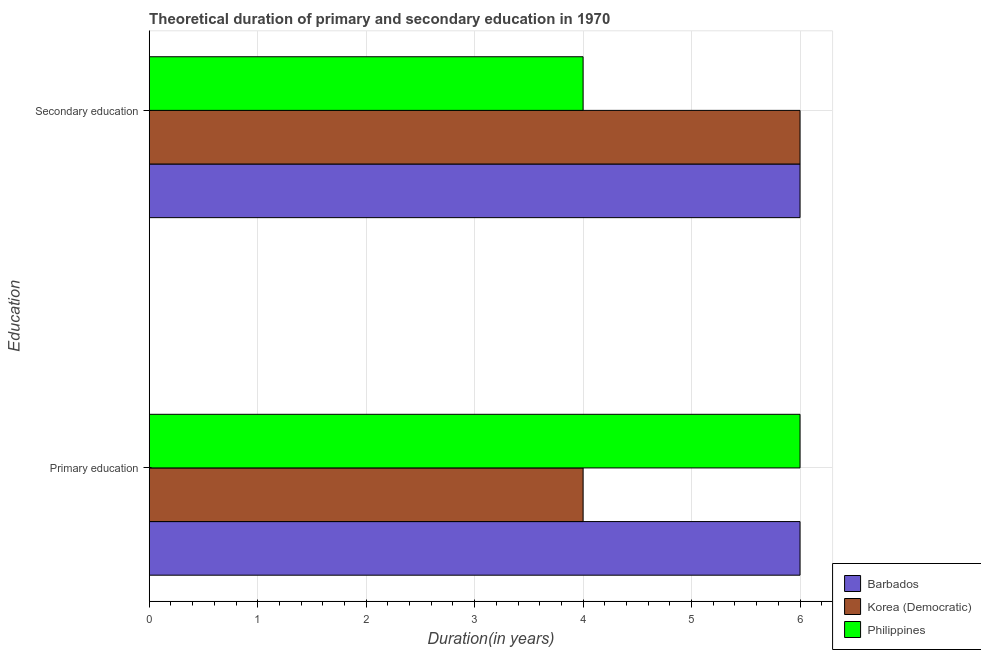How many different coloured bars are there?
Provide a short and direct response. 3. How many groups of bars are there?
Provide a succinct answer. 2. How many bars are there on the 1st tick from the bottom?
Provide a short and direct response. 3. What is the duration of secondary education in Barbados?
Keep it short and to the point. 6. Across all countries, what is the minimum duration of primary education?
Provide a short and direct response. 4. In which country was the duration of primary education maximum?
Offer a very short reply. Barbados. In which country was the duration of secondary education minimum?
Your response must be concise. Philippines. What is the total duration of secondary education in the graph?
Your answer should be compact. 16. What is the difference between the duration of secondary education in Philippines and that in Korea (Democratic)?
Keep it short and to the point. -2. What is the average duration of secondary education per country?
Ensure brevity in your answer.  5.33. What is the ratio of the duration of primary education in Korea (Democratic) to that in Philippines?
Provide a succinct answer. 0.67. Is the duration of primary education in Philippines less than that in Korea (Democratic)?
Keep it short and to the point. No. What does the 1st bar from the top in Primary education represents?
Your answer should be very brief. Philippines. What does the 1st bar from the bottom in Secondary education represents?
Your answer should be compact. Barbados. How many bars are there?
Your answer should be very brief. 6. Are all the bars in the graph horizontal?
Provide a short and direct response. Yes. How many countries are there in the graph?
Offer a terse response. 3. Does the graph contain any zero values?
Make the answer very short. No. How many legend labels are there?
Offer a terse response. 3. How are the legend labels stacked?
Your response must be concise. Vertical. What is the title of the graph?
Provide a succinct answer. Theoretical duration of primary and secondary education in 1970. Does "World" appear as one of the legend labels in the graph?
Provide a short and direct response. No. What is the label or title of the X-axis?
Your answer should be very brief. Duration(in years). What is the label or title of the Y-axis?
Offer a very short reply. Education. What is the Duration(in years) in Barbados in Primary education?
Ensure brevity in your answer.  6. What is the Duration(in years) of Korea (Democratic) in Primary education?
Provide a succinct answer. 4. What is the Duration(in years) in Barbados in Secondary education?
Provide a short and direct response. 6. What is the Duration(in years) of Korea (Democratic) in Secondary education?
Your answer should be very brief. 6. Across all Education, what is the maximum Duration(in years) of Barbados?
Ensure brevity in your answer.  6. Across all Education, what is the minimum Duration(in years) in Barbados?
Offer a terse response. 6. Across all Education, what is the minimum Duration(in years) of Korea (Democratic)?
Ensure brevity in your answer.  4. Across all Education, what is the minimum Duration(in years) of Philippines?
Your response must be concise. 4. What is the total Duration(in years) of Barbados in the graph?
Your response must be concise. 12. What is the total Duration(in years) of Korea (Democratic) in the graph?
Give a very brief answer. 10. What is the total Duration(in years) of Philippines in the graph?
Your answer should be compact. 10. What is the difference between the Duration(in years) in Barbados in Primary education and the Duration(in years) in Korea (Democratic) in Secondary education?
Give a very brief answer. 0. What is the average Duration(in years) of Barbados per Education?
Provide a succinct answer. 6. What is the average Duration(in years) of Korea (Democratic) per Education?
Offer a terse response. 5. What is the average Duration(in years) in Philippines per Education?
Make the answer very short. 5. What is the difference between the Duration(in years) of Korea (Democratic) and Duration(in years) of Philippines in Primary education?
Make the answer very short. -2. What is the difference between the Duration(in years) of Barbados and Duration(in years) of Korea (Democratic) in Secondary education?
Your response must be concise. 0. What is the difference between the Duration(in years) in Barbados and Duration(in years) in Philippines in Secondary education?
Keep it short and to the point. 2. What is the difference between the Duration(in years) in Korea (Democratic) and Duration(in years) in Philippines in Secondary education?
Your answer should be very brief. 2. What is the ratio of the Duration(in years) of Korea (Democratic) in Primary education to that in Secondary education?
Your answer should be very brief. 0.67. What is the ratio of the Duration(in years) in Philippines in Primary education to that in Secondary education?
Offer a terse response. 1.5. What is the difference between the highest and the second highest Duration(in years) in Barbados?
Provide a short and direct response. 0. What is the difference between the highest and the second highest Duration(in years) in Korea (Democratic)?
Your response must be concise. 2. What is the difference between the highest and the second highest Duration(in years) of Philippines?
Make the answer very short. 2. What is the difference between the highest and the lowest Duration(in years) in Barbados?
Your answer should be compact. 0. 